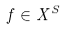<formula> <loc_0><loc_0><loc_500><loc_500>f \in X ^ { S }</formula> 